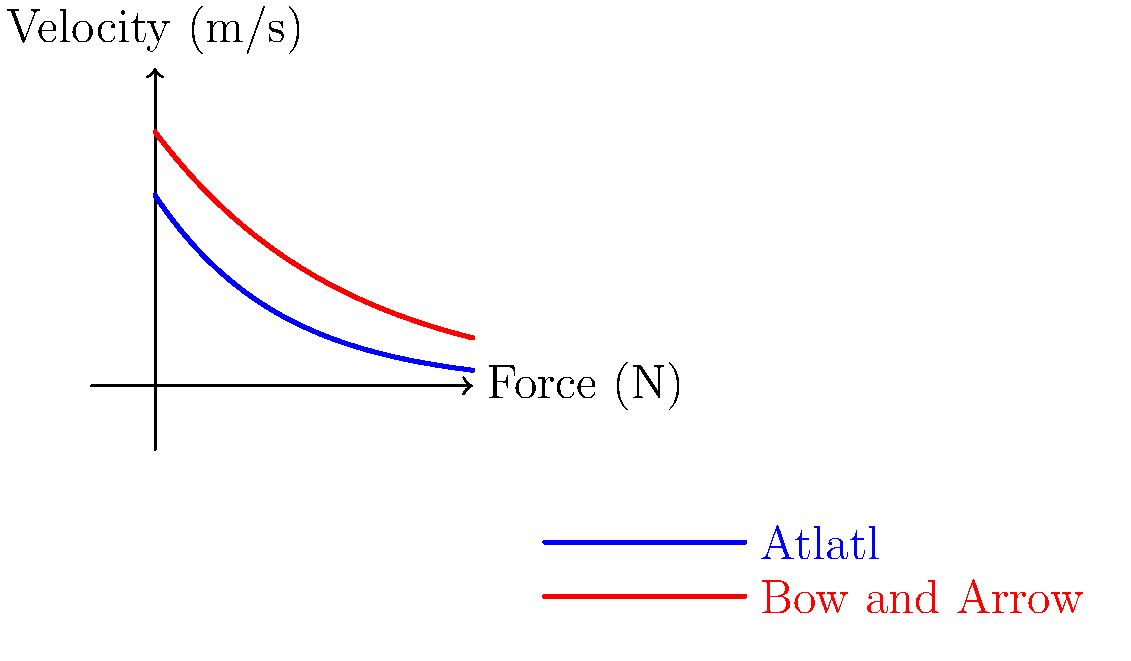Based on the force-velocity curves shown in the diagram for two Native American hunting tools (atlatl and bow and arrow), which tool demonstrates higher biomechanical efficiency at lower velocities? Explain your reasoning using the concepts of power output and area under the curve. To determine which tool demonstrates higher biomechanical efficiency at lower velocities, we need to analyze the force-velocity curves and consider the concepts of power output and area under the curve. Let's break this down step-by-step:

1. Observe the curves:
   - Blue curve represents the atlatl
   - Red curve represents the bow and arrow

2. Compare the curves at lower velocities (left side of the graph):
   - The atlatl curve (blue) starts at a higher force value
   - The bow and arrow curve (red) starts at a slightly lower force value

3. Consider power output:
   - Power is calculated as the product of force and velocity: $P = F \times v$
   - At lower velocities, the atlatl produces more force, resulting in higher power output

4. Analyze the area under the curve:
   - The area under the force-velocity curve represents the work done or energy transfer
   - At lower velocities, the area under the atlatl curve is greater than the bow and arrow curve

5. Biomechanical efficiency:
   - Higher power output and greater energy transfer at lower velocities indicate better efficiency
   - The atlatl curve shows these characteristics at lower velocities

6. Consider the trade-offs:
   - While the atlatl is more efficient at lower velocities, the bow and arrow maintains higher force levels at higher velocities
   - This suggests that each tool has its own advantages in different hunting scenarios

Based on this analysis, the atlatl demonstrates higher biomechanical efficiency at lower velocities due to its higher initial force output and greater area under the curve in this region.
Answer: Atlatl 